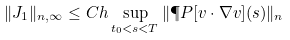Convert formula to latex. <formula><loc_0><loc_0><loc_500><loc_500>\| J _ { 1 } \| _ { n , \infty } \leq C h \sup _ { t _ { 0 } < s < T } \| \P P [ v \cdot \nabla v ] ( s ) \| _ { n }</formula> 